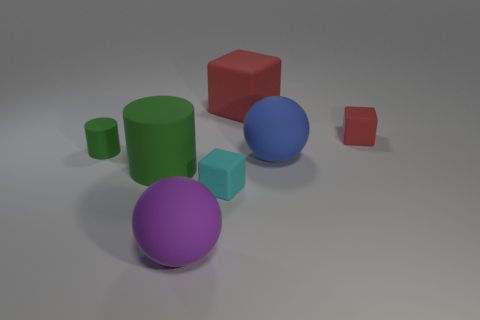Add 3 blue cubes. How many objects exist? 10 Subtract all cubes. How many objects are left? 4 Add 5 yellow matte balls. How many yellow matte balls exist? 5 Subtract 0 green cubes. How many objects are left? 7 Subtract all big blue rubber things. Subtract all cyan objects. How many objects are left? 5 Add 6 tiny cyan matte things. How many tiny cyan matte things are left? 7 